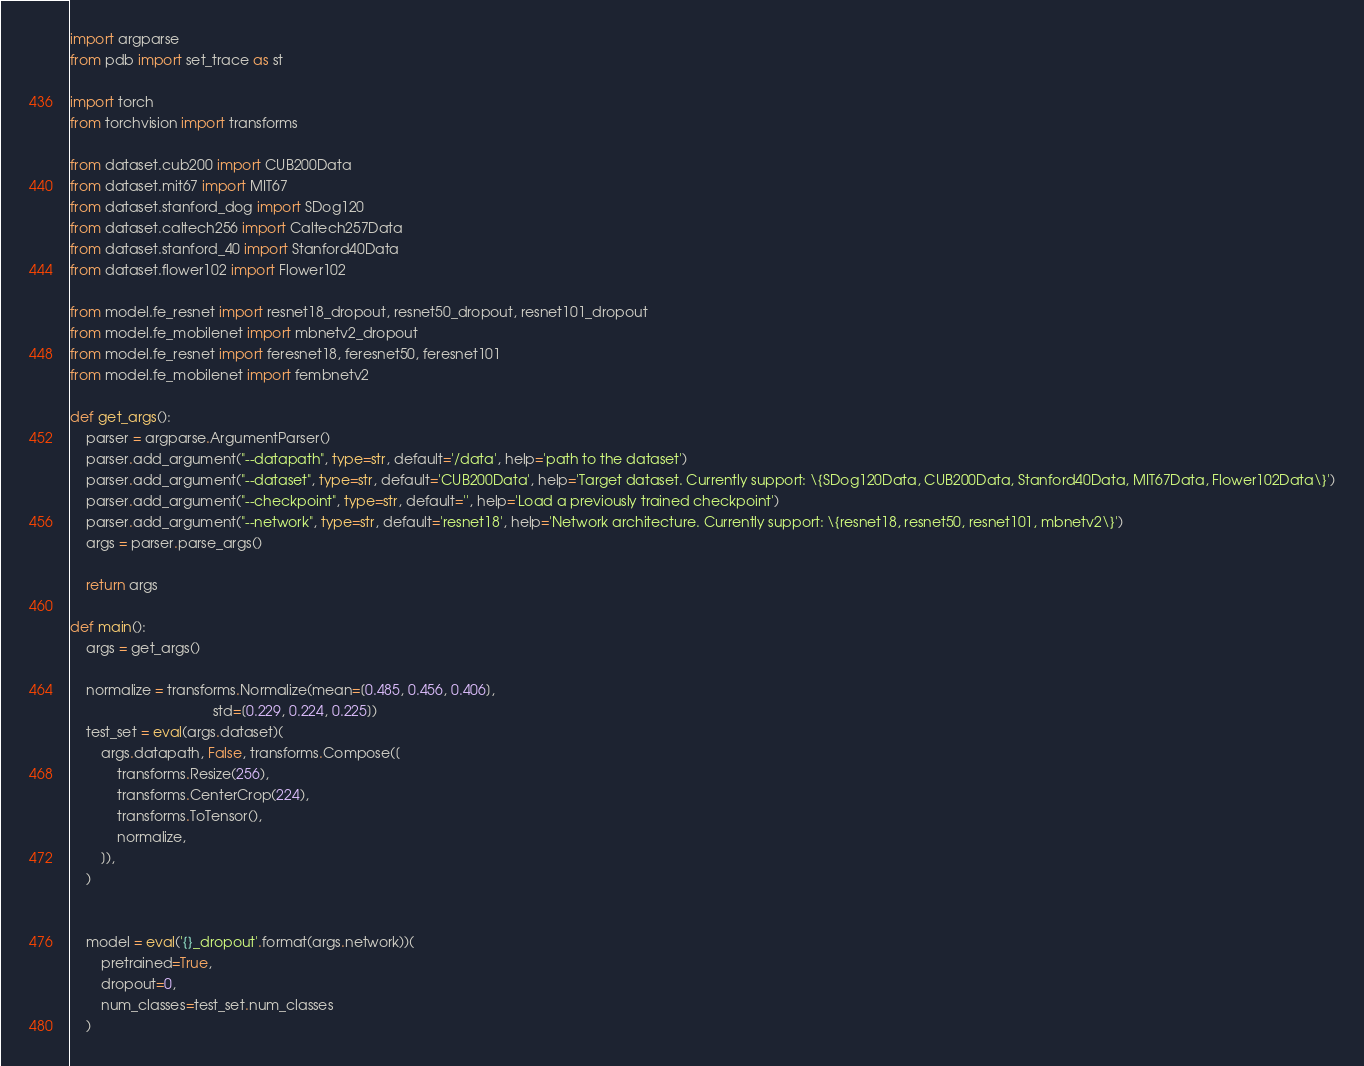<code> <loc_0><loc_0><loc_500><loc_500><_Python_>import argparse
from pdb import set_trace as st

import torch
from torchvision import transforms

from dataset.cub200 import CUB200Data
from dataset.mit67 import MIT67
from dataset.stanford_dog import SDog120
from dataset.caltech256 import Caltech257Data
from dataset.stanford_40 import Stanford40Data
from dataset.flower102 import Flower102

from model.fe_resnet import resnet18_dropout, resnet50_dropout, resnet101_dropout
from model.fe_mobilenet import mbnetv2_dropout
from model.fe_resnet import feresnet18, feresnet50, feresnet101
from model.fe_mobilenet import fembnetv2

def get_args():
    parser = argparse.ArgumentParser()
    parser.add_argument("--datapath", type=str, default='/data', help='path to the dataset')
    parser.add_argument("--dataset", type=str, default='CUB200Data', help='Target dataset. Currently support: \{SDog120Data, CUB200Data, Stanford40Data, MIT67Data, Flower102Data\}')
    parser.add_argument("--checkpoint", type=str, default='', help='Load a previously trained checkpoint')
    parser.add_argument("--network", type=str, default='resnet18', help='Network architecture. Currently support: \{resnet18, resnet50, resnet101, mbnetv2\}')
    args = parser.parse_args()
    
    return args

def main():
    args = get_args()
    
    normalize = transforms.Normalize(mean=[0.485, 0.456, 0.406],
                                     std=[0.229, 0.224, 0.225])
    test_set = eval(args.dataset)(
        args.datapath, False, transforms.Compose([
            transforms.Resize(256),
            transforms.CenterCrop(224),
            transforms.ToTensor(),
            normalize,
        ]), 
    )
    
    
    model = eval('{}_dropout'.format(args.network))(
        pretrained=True, 
        dropout=0, 
        num_classes=test_set.num_classes
    )
</code> 